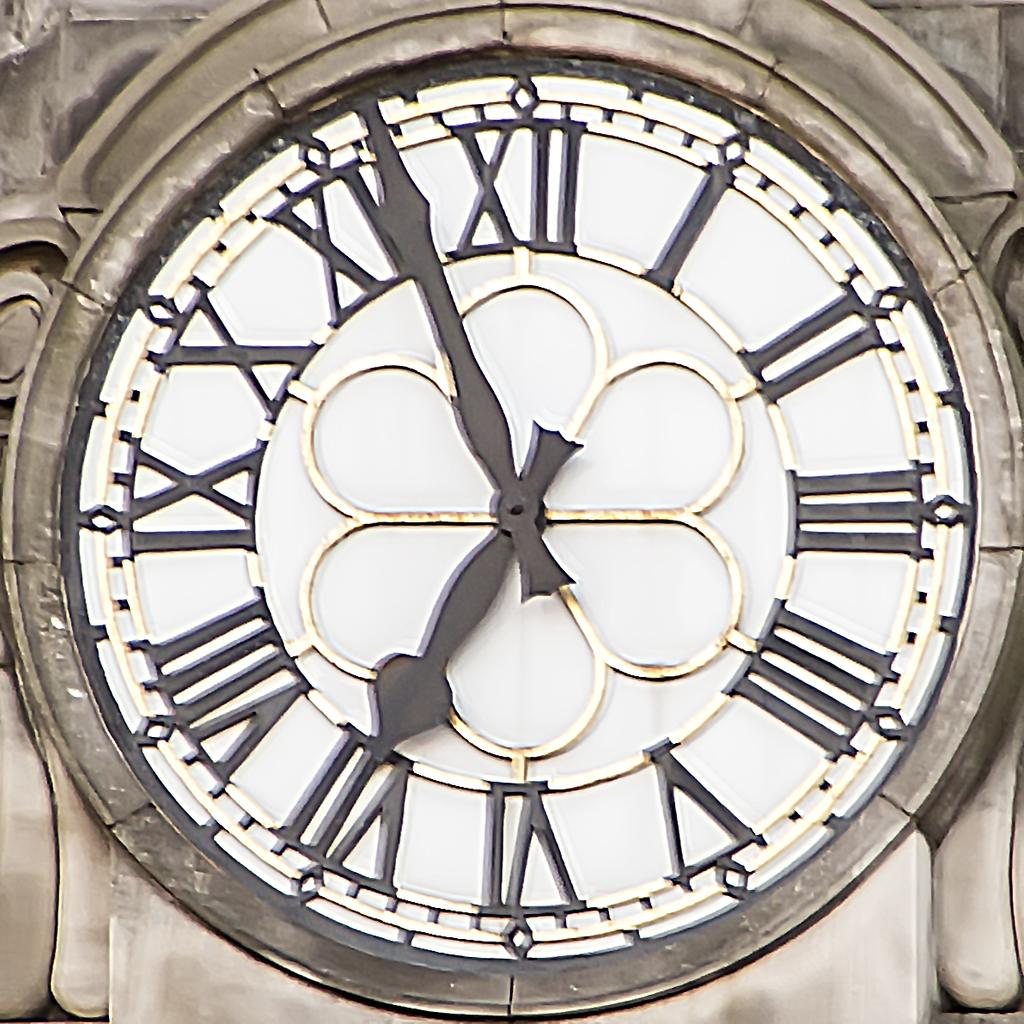What is the main object in the middle of the image? There is a clock in the middle of the image. Where is the clock located? The clock is on the wall. What other decorative features can be seen on the wall? There are carvings on the wall. What type of face is depicted on the clock in the image? There is no face depicted on the clock in the image; it is a clock with numbers and hands. 